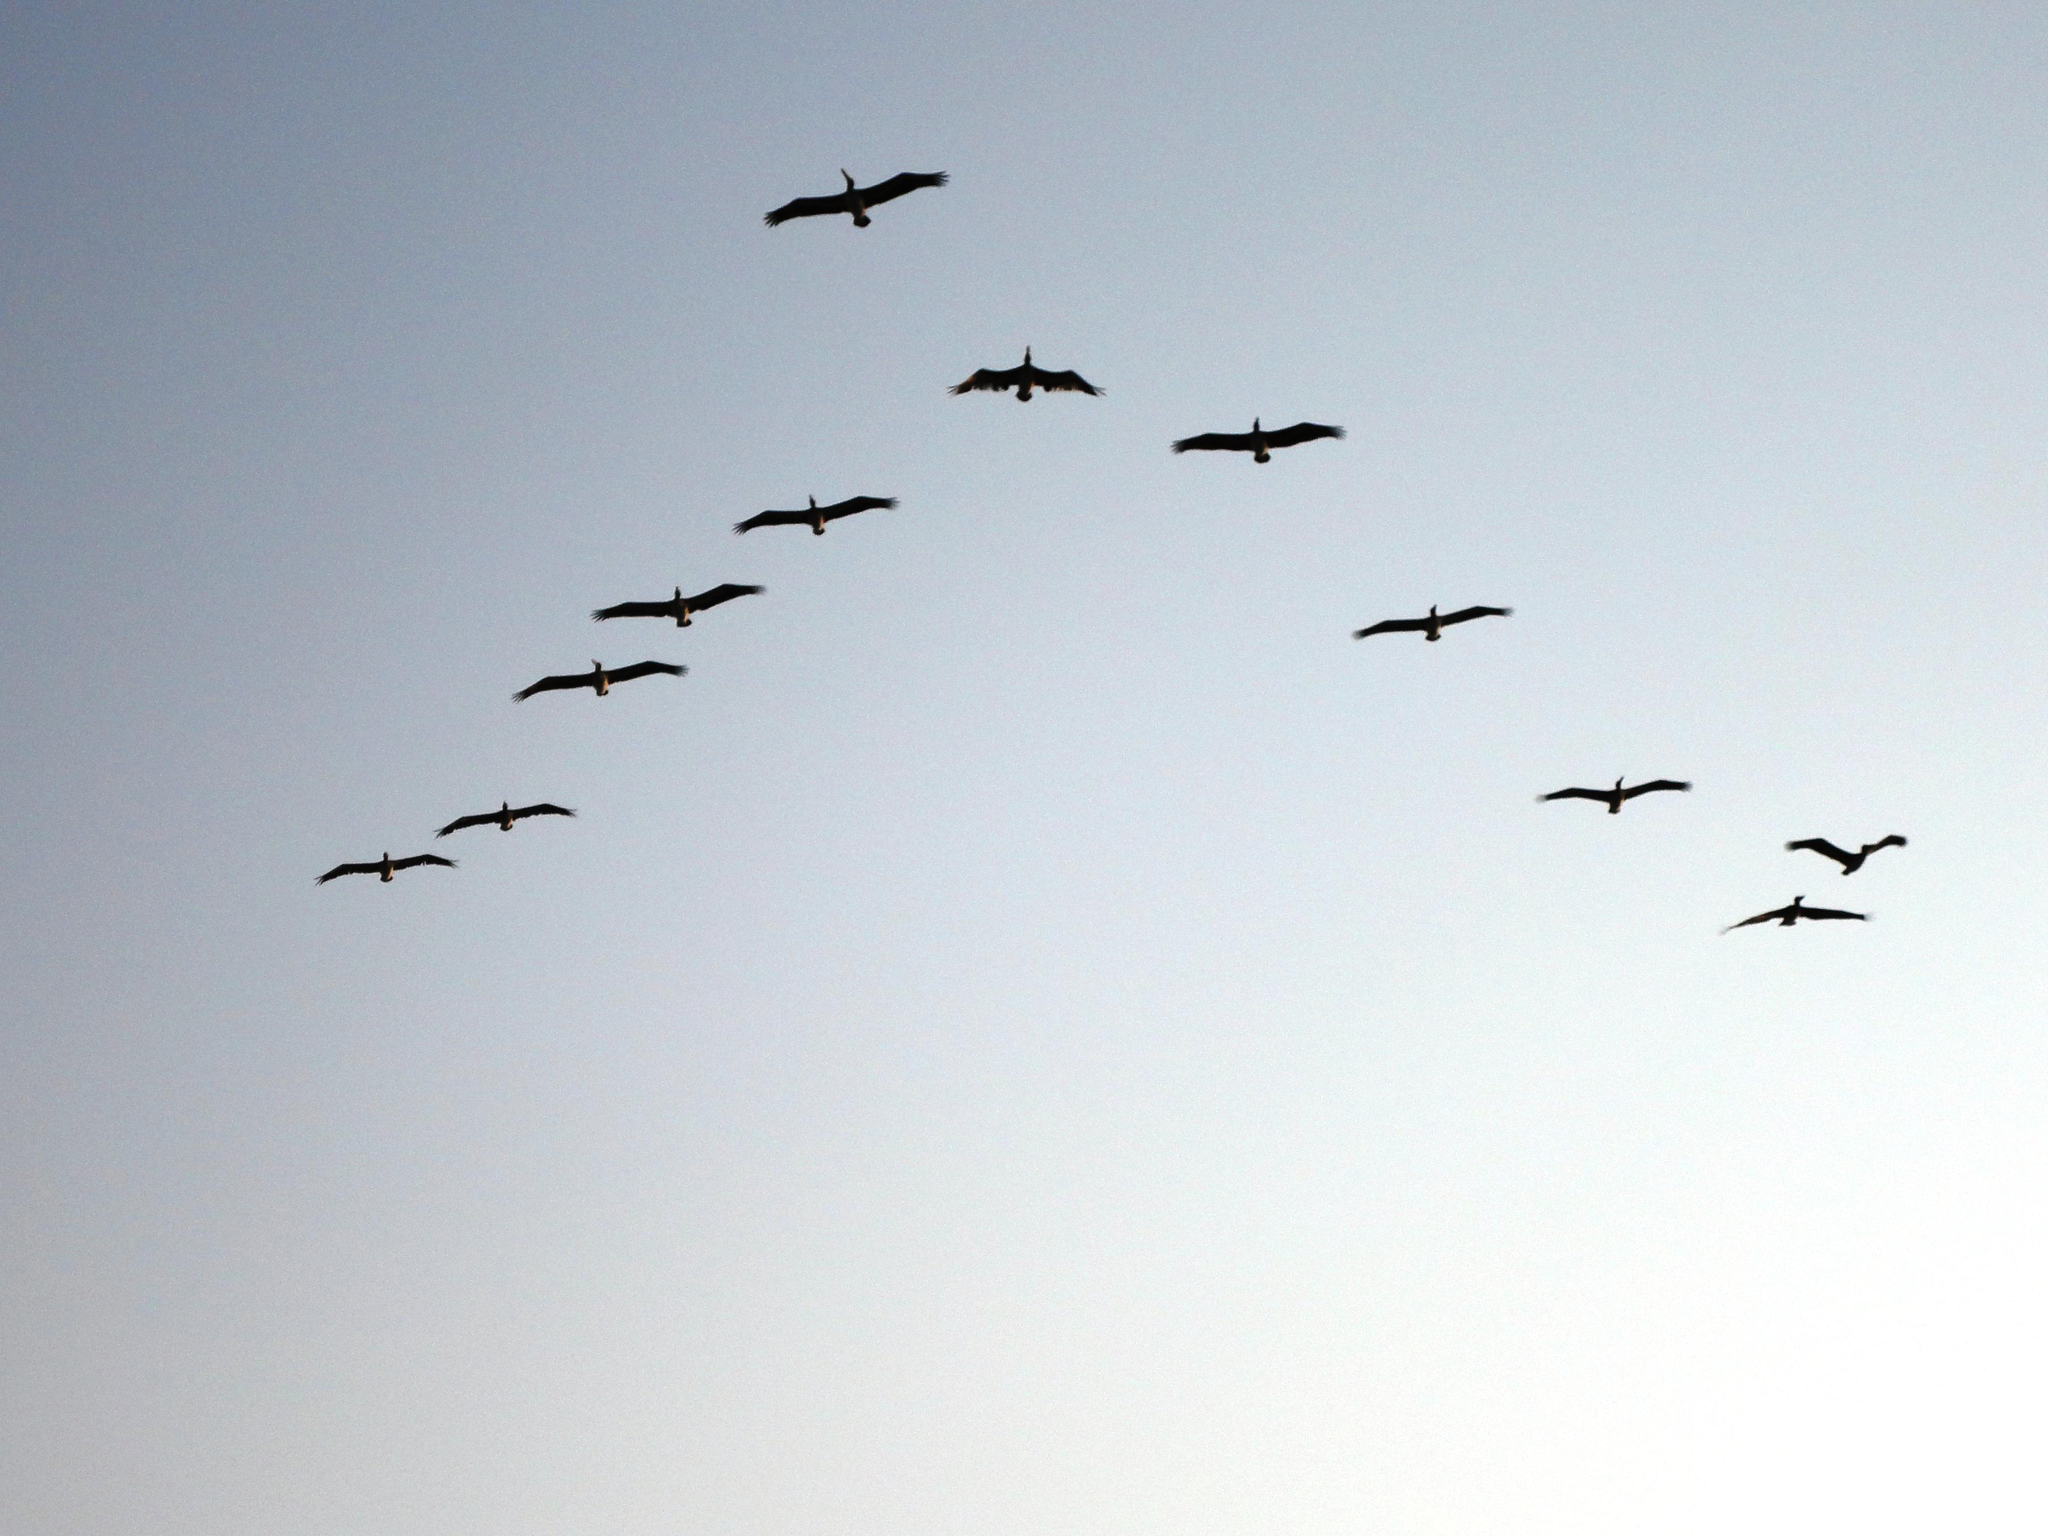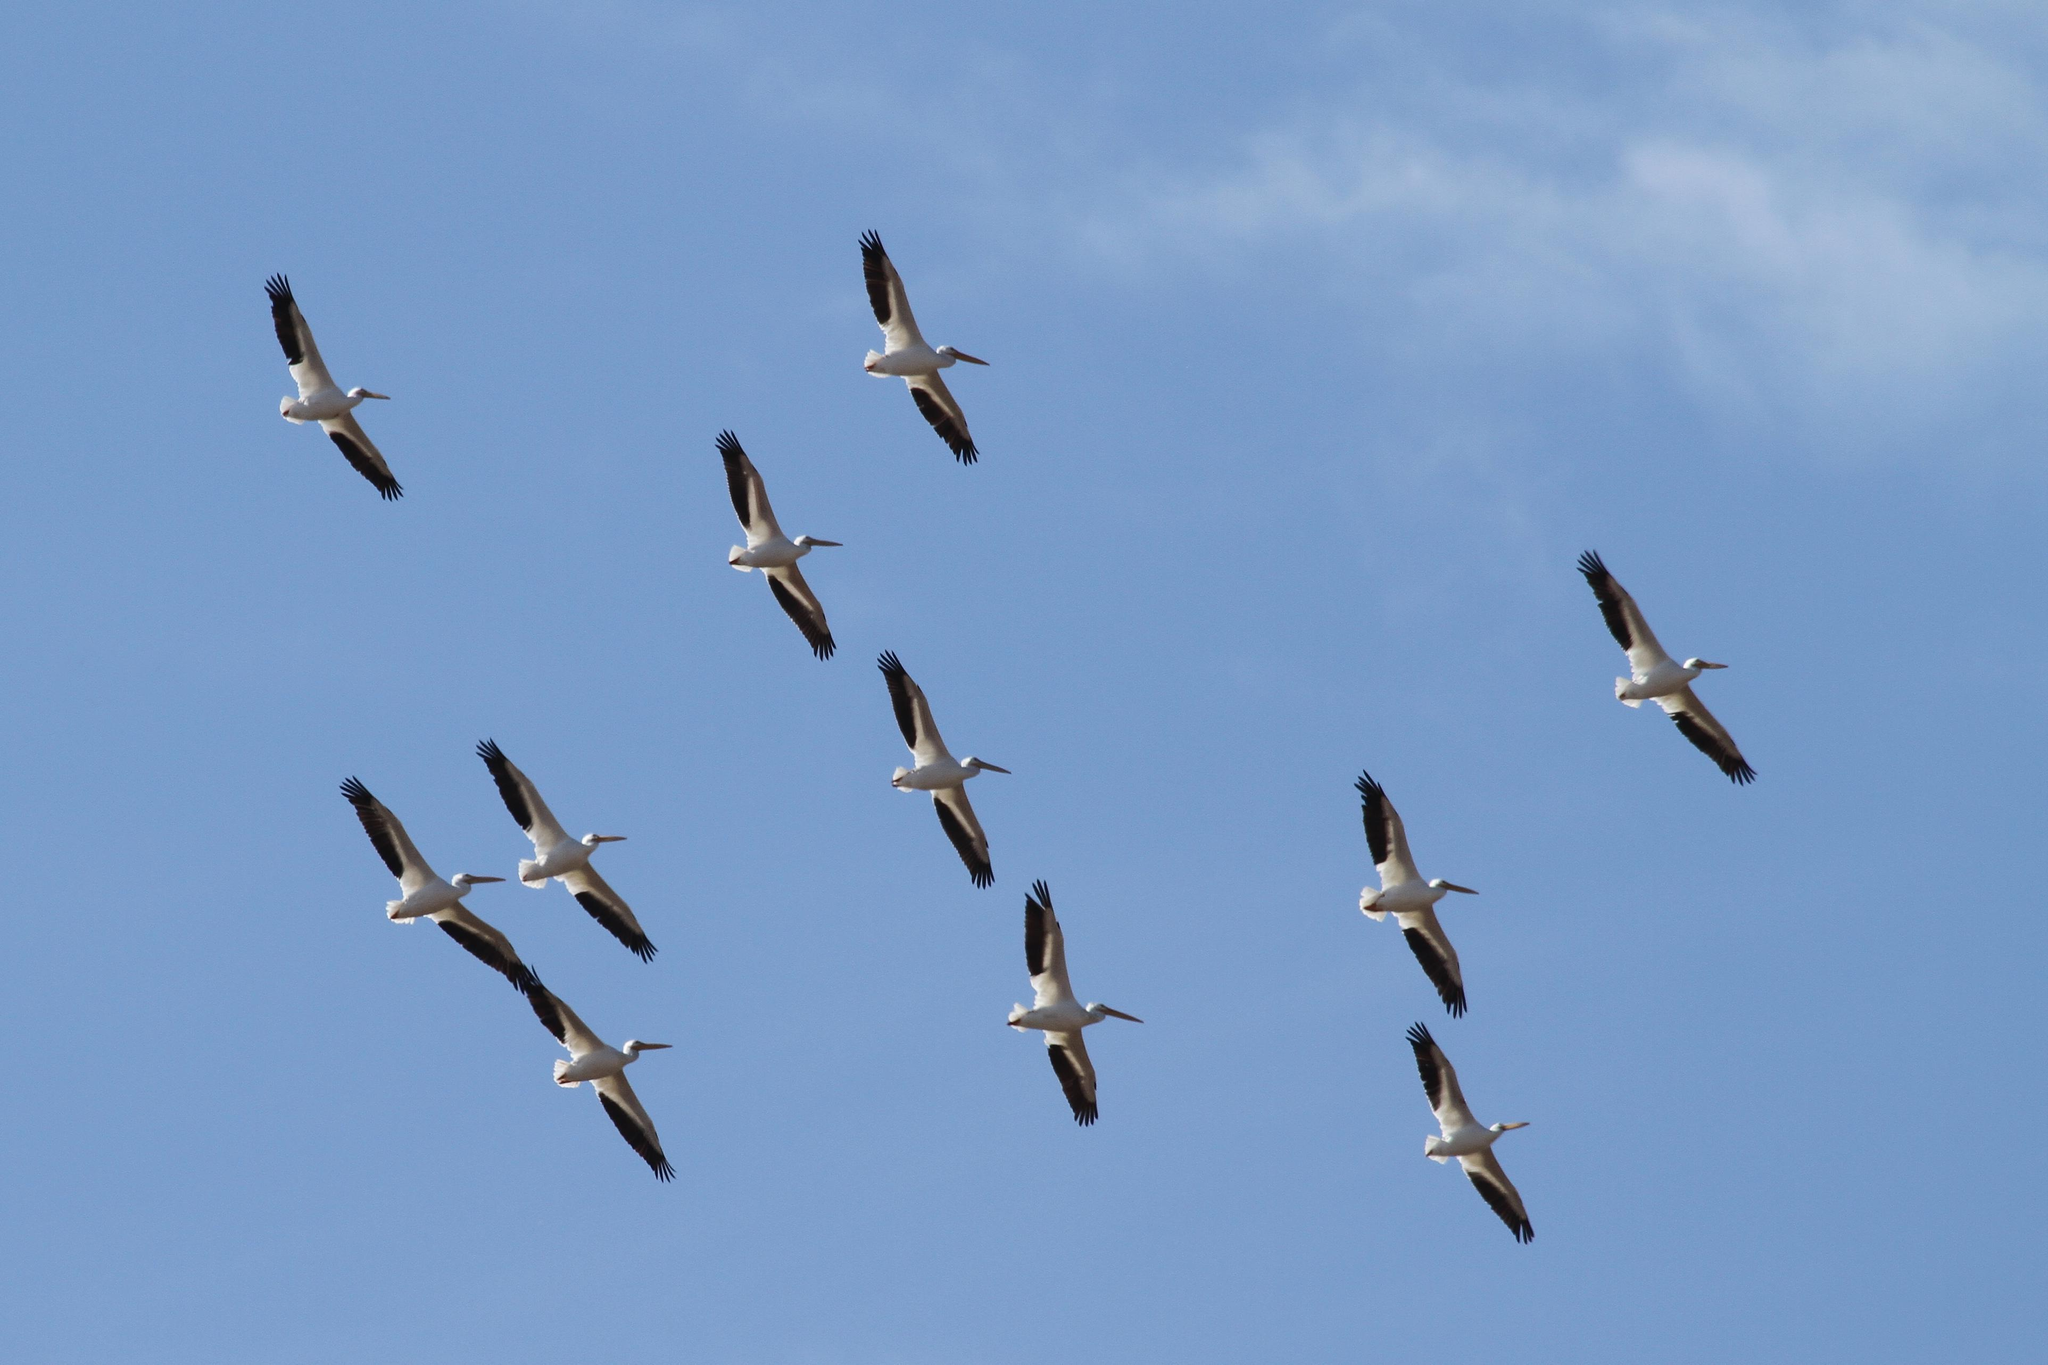The first image is the image on the left, the second image is the image on the right. For the images displayed, is the sentence "In one image there are some birds above the water." factually correct? Answer yes or no. No. The first image is the image on the left, the second image is the image on the right. Assess this claim about the two images: "The right image contains a wispy cloud and birds flying in formation.". Correct or not? Answer yes or no. Yes. 